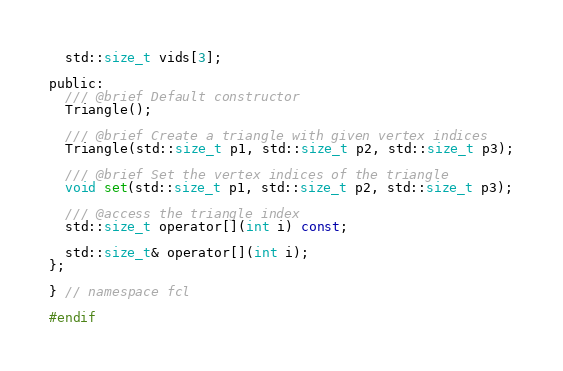Convert code to text. <code><loc_0><loc_0><loc_500><loc_500><_C_>  std::size_t vids[3];

public:
  /// @brief Default constructor
  Triangle();

  /// @brief Create a triangle with given vertex indices
  Triangle(std::size_t p1, std::size_t p2, std::size_t p3);

  /// @brief Set the vertex indices of the triangle
  void set(std::size_t p1, std::size_t p2, std::size_t p3);

  /// @access the triangle index
  std::size_t operator[](int i) const;

  std::size_t& operator[](int i);
};

} // namespace fcl

#endif
</code> 